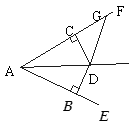What mathematical property confirms the equality of angles BAD and CAD? The equality of angles BAD and CAD is confirmed by the use of the Vertical Angle Theorem, which states that opposite angles made by two intersecting lines are equal. This property is essential in understanding the congruence of triangles ADB and ADC. 